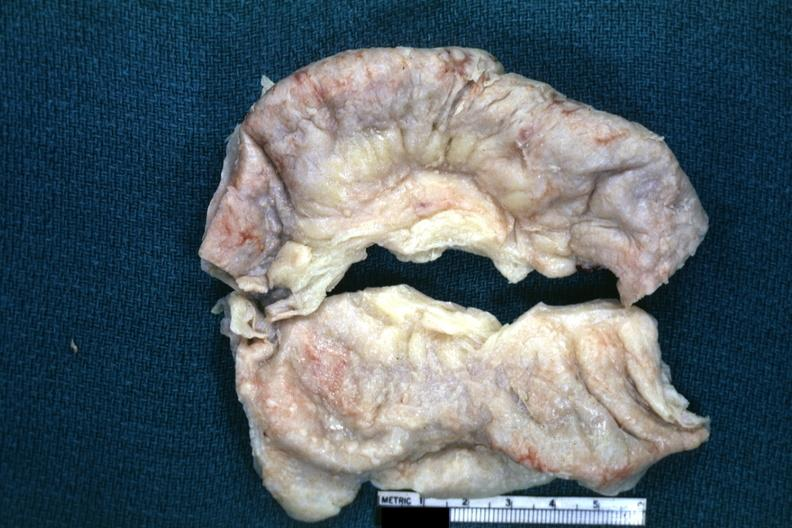where is this area in the body?
Answer the question using a single word or phrase. Abdomen 